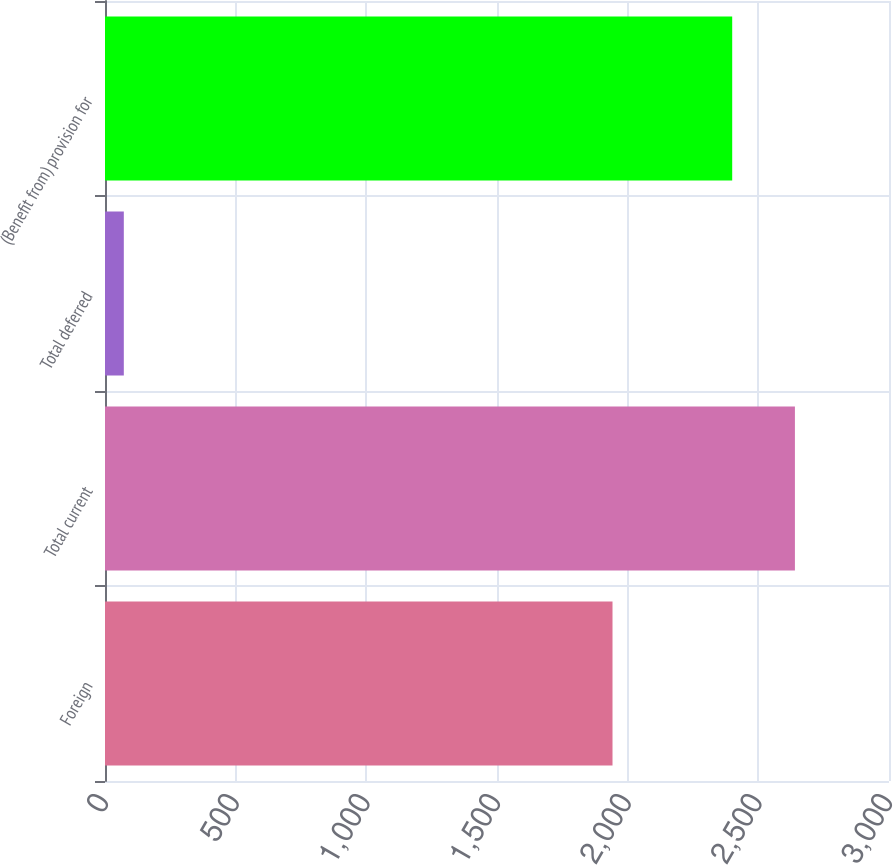Convert chart to OTSL. <chart><loc_0><loc_0><loc_500><loc_500><bar_chart><fcel>Foreign<fcel>Total current<fcel>Total deferred<fcel>(Benefit from) provision for<nl><fcel>1942<fcel>2640<fcel>72<fcel>2400<nl></chart> 